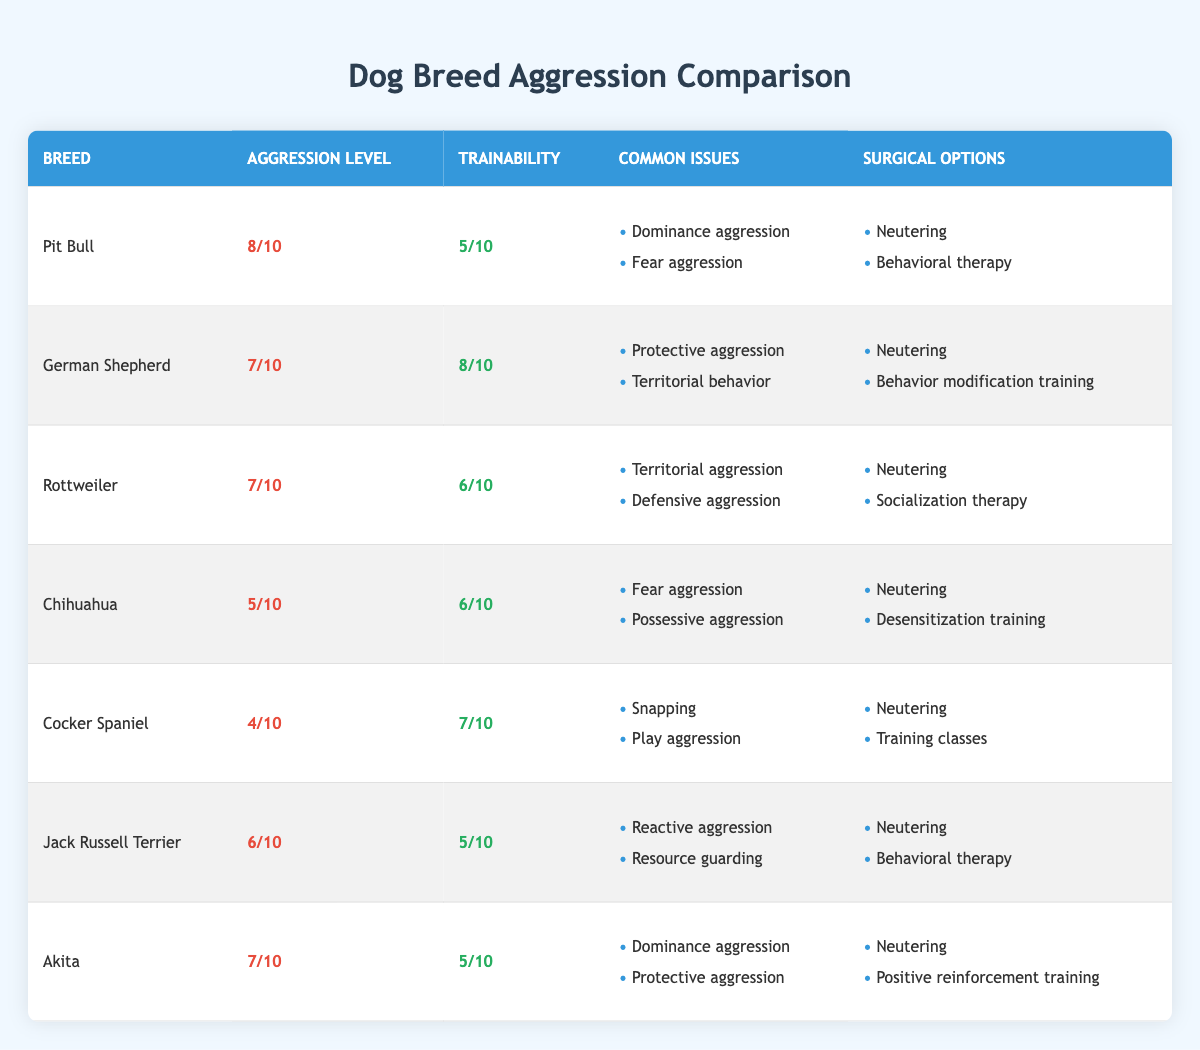What is the aggression level of a Pit Bull? The aggression level of a Pit Bull is listed directly in the table under the Aggression Level column. It shows an aggression level of 8/10.
Answer: 8/10 Which breed has the highest trainability score? The table includes a Trainability column where the highest score can be found by scanning through the values. The German Shepherd has the highest trainability score of 8/10.
Answer: German Shepherd Do Rottweilers have common issues with territorial aggression? The common issues for Rottweilers are noted in the table, and one of them listed is territorial aggression, confirming that it is indeed a common issue.
Answer: Yes What are the surgical options available for a Chihuahua? To find the surgical options, we can look at the specific row for the Chihuahua in the table. The options listed are neutering and desensitization training.
Answer: Neutering, desensitization training How many breeds have an aggression level of 7 or higher? We need to evaluate the Aggression Level column and count the breeds that have an aggression level of 7 or higher. The breeds are: Pit Bull, German Shepherd, Rottweiler, and Akita, making a total of 4 breeds.
Answer: 4 Which breed has the lowest aggression level and what is it? The table lists aggression levels for all breeds. By reviewing the levels, we find that the Cocker Spaniel has the lowest aggression level of 4/10.
Answer: Cocker Spaniel, 4/10 Are there any breeds listed that do not have neutering as a surgical option? A review of the table shows that for every breed listed, neutering is indeed one of the surgical options available, confirming that no breeds lack neutering as an option.
Answer: No What is the average aggression level of all breeds listed? To calculate the average, we sum the aggression levels of all breeds (8 + 7 + 7 + 5 + 4 + 6 + 7) which equals 49. Then, we divide this sum by the number of breeds (7). So, 49/7 = 7.
Answer: 7 What behavioral issues are associated with Akitas? By locating the Akita row in the table, we can identify the common issues listed: dominance aggression and protective aggression, which indicates the behavioral challenges associated with this breed.
Answer: Dominance aggression, protective aggression 